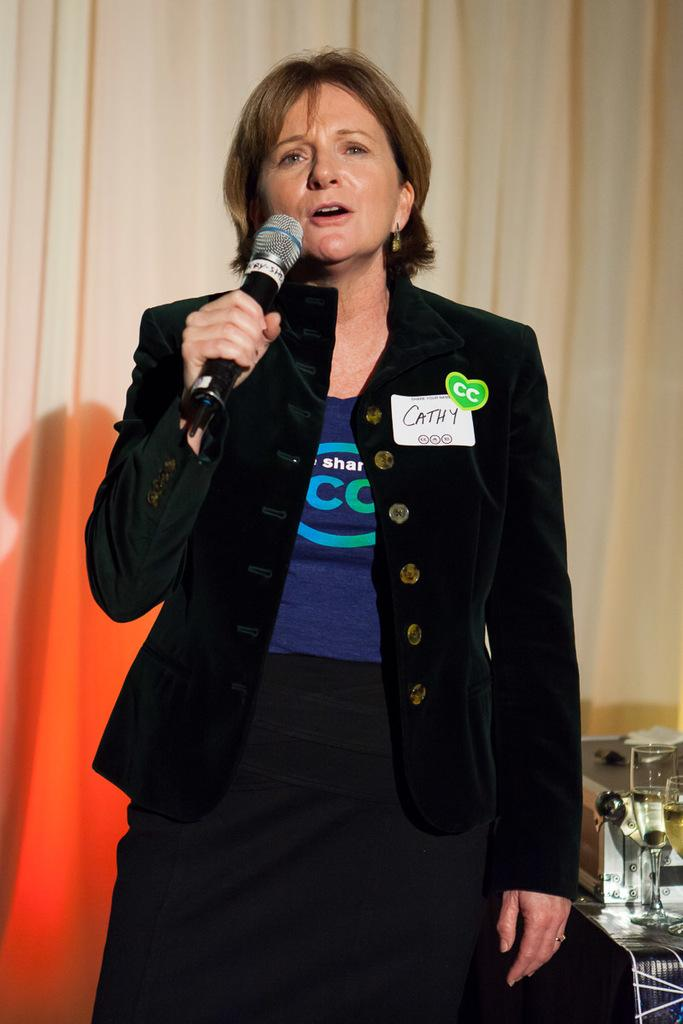Who is the main subject in the image? There is a woman in the center of the image. What is the woman holding in the image? The woman is holding a microphone. What can be seen in the background of the image? There is a curtain visible in the background of the image. How many worms can be seen crawling on the tray in the image? There is no tray or worms present in the image. 